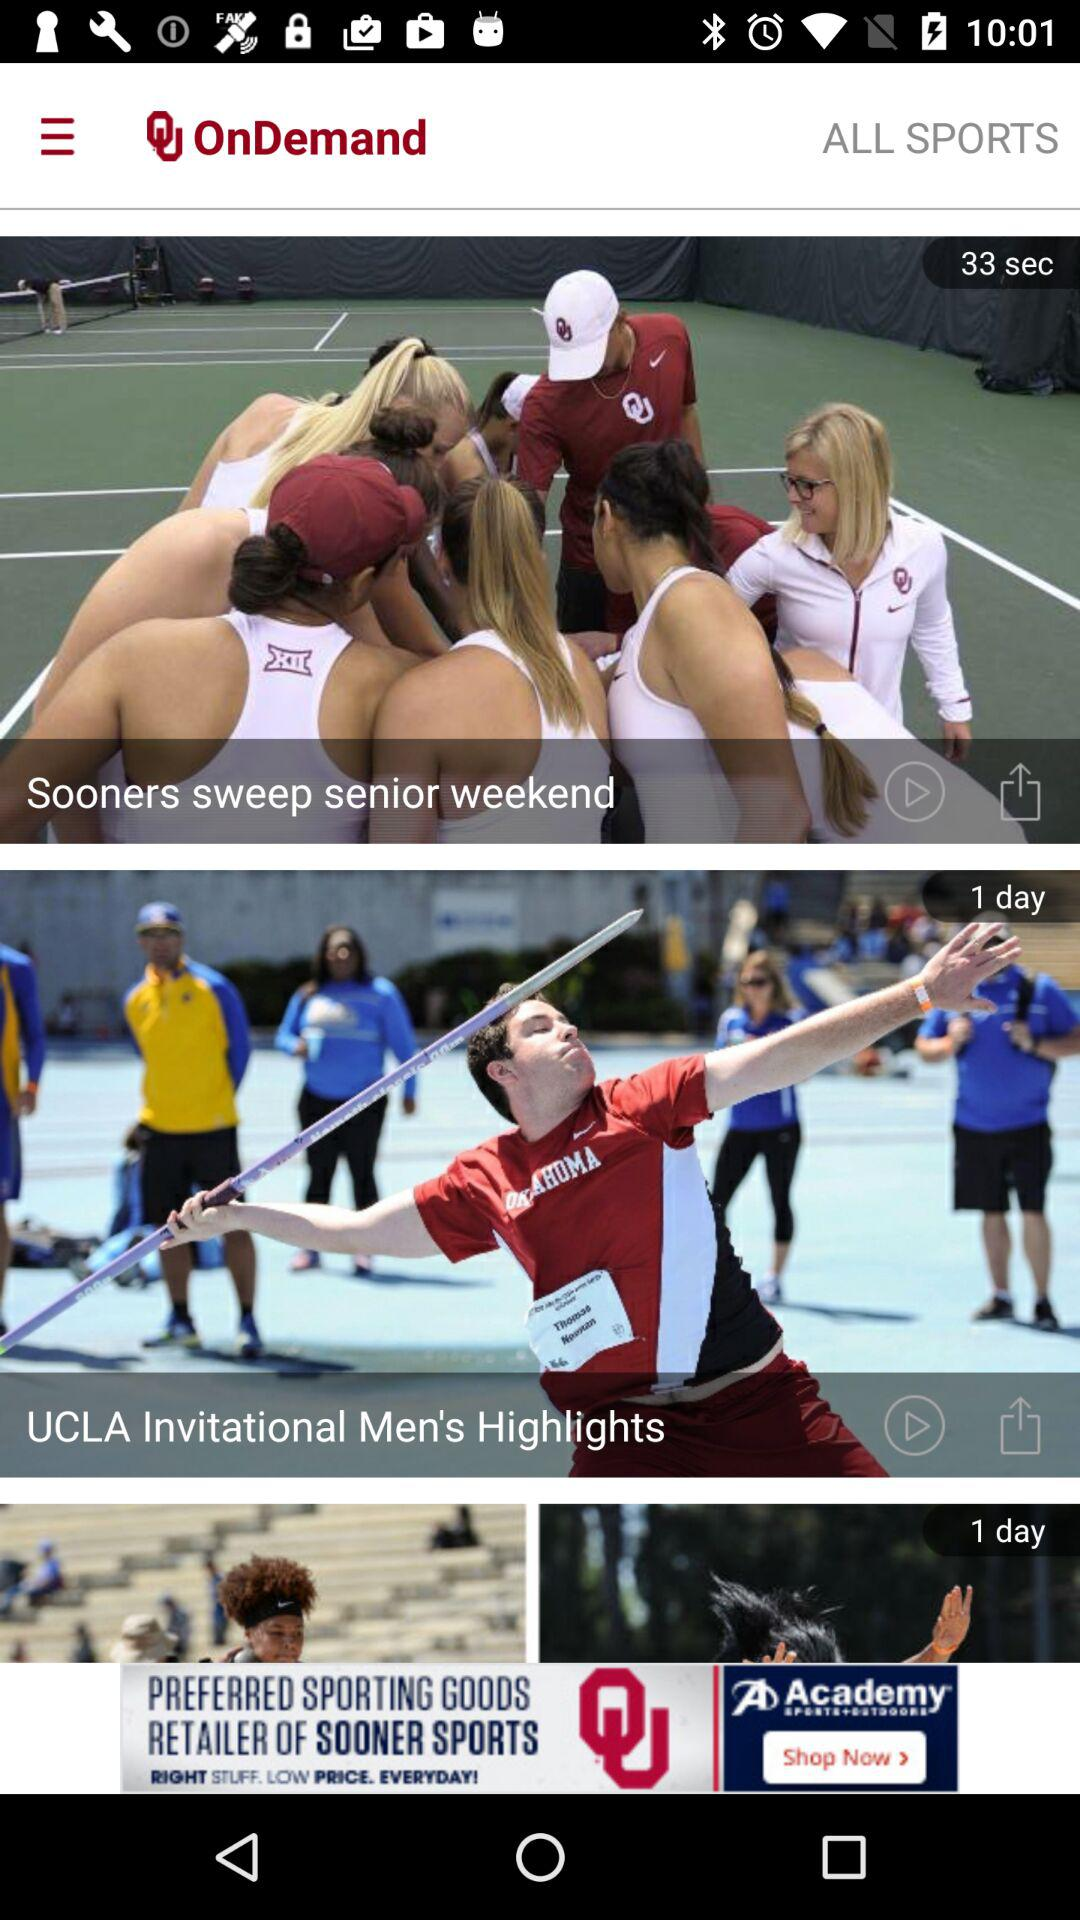What is the application name? The application name is "University of Oklahoma". 